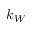Convert formula to latex. <formula><loc_0><loc_0><loc_500><loc_500>k _ { W }</formula> 